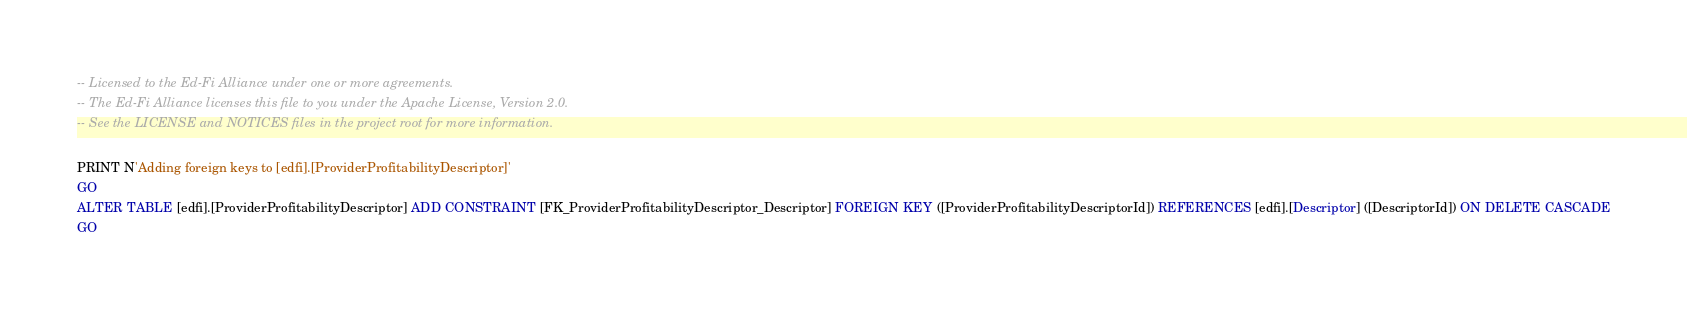Convert code to text. <code><loc_0><loc_0><loc_500><loc_500><_SQL_>-- Licensed to the Ed-Fi Alliance under one or more agreements.
-- The Ed-Fi Alliance licenses this file to you under the Apache License, Version 2.0.
-- See the LICENSE and NOTICES files in the project root for more information.

PRINT N'Adding foreign keys to [edfi].[ProviderProfitabilityDescriptor]'
GO
ALTER TABLE [edfi].[ProviderProfitabilityDescriptor] ADD CONSTRAINT [FK_ProviderProfitabilityDescriptor_Descriptor] FOREIGN KEY ([ProviderProfitabilityDescriptorId]) REFERENCES [edfi].[Descriptor] ([DescriptorId]) ON DELETE CASCADE
GO
</code> 